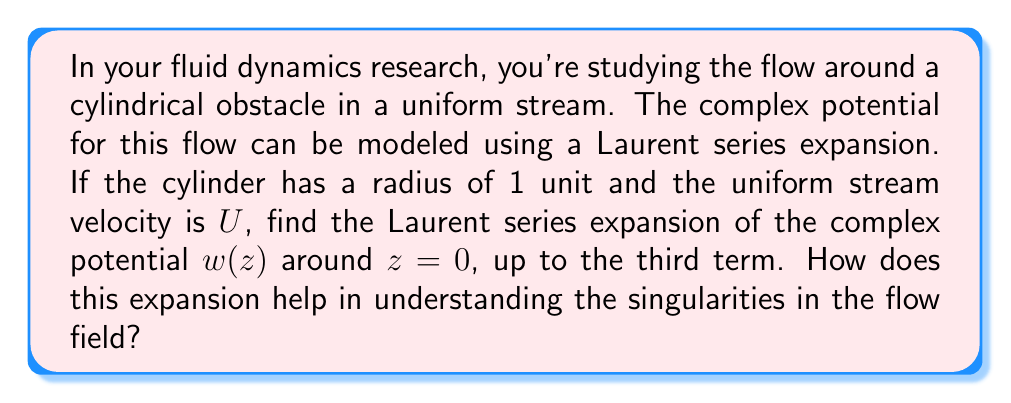Solve this math problem. Let's approach this step-by-step:

1) The complex potential for a uniform stream past a circular cylinder is given by:

   $$w(z) = U(z + \frac{1}{z})$$

2) To find the Laurent series expansion around $z = 0$, we need to expand this function in terms of positive and negative powers of $z$:

   $$w(z) = U(z + z^{-1})$$

3) This is already in the form of a Laurent series. Let's write it out to the third term:

   $$w(z) = Uz^{-1} + Uz + 0z^2 + 0z^3 + ...$$

4) The Laurent series helps us understand the singularities in the flow field:

   a) The term $Uz^{-1}$ represents a simple pole at $z = 0$. This corresponds to a source-sink pair at the origin, which models the presence of the cylinder.
   
   b) The term $Uz$ represents the uniform stream.
   
   c) The absence of higher-order terms indicates that there are no other singularities in the flow field.

5) The singularity at $z = 0$ is essential for modeling the cylinder's effect on the flow. It creates the circulation around the cylinder and ensures that the cylinder surface becomes a streamline of the flow.

6) By analyzing the coefficients of the Laurent series, we can determine:
   - The strength of the source-sink pair (given by the coefficient of $z^{-1}$)
   - The uniform stream velocity (given by the coefficient of $z$)

This Laurent series expansion provides a powerful tool for analyzing the flow structure and singularities in this fluid dynamics problem, allowing us to understand the behavior of the flow field at different distances from the cylinder.
Answer: The Laurent series expansion of the complex potential $w(z)$ around $z = 0$, up to the third term, is:

$$w(z) = Uz^{-1} + Uz + 0z^2$$

This expansion helps understand the singularities by revealing a simple pole at $z = 0$ (representing the cylinder's effect) and the uniform stream term, while showing no higher-order singularities in the flow field. 